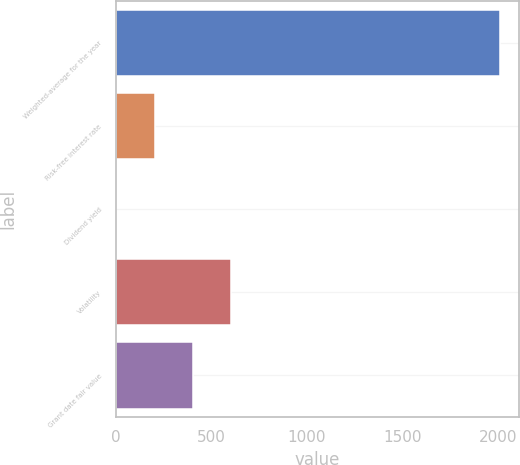Convert chart. <chart><loc_0><loc_0><loc_500><loc_500><bar_chart><fcel>Weighted-average for the year<fcel>Risk-free interest rate<fcel>Dividend yield<fcel>Volatility<fcel>Grant date fair value<nl><fcel>2011<fcel>201.64<fcel>0.6<fcel>603.72<fcel>402.68<nl></chart> 